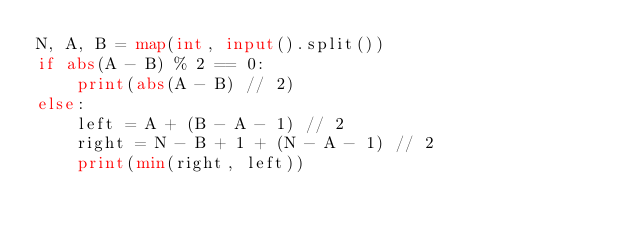Convert code to text. <code><loc_0><loc_0><loc_500><loc_500><_Python_>N, A, B = map(int, input().split())
if abs(A - B) % 2 == 0:
    print(abs(A - B) // 2)
else:
    left = A + (B - A - 1) // 2
    right = N - B + 1 + (N - A - 1) // 2
    print(min(right, left))
</code> 